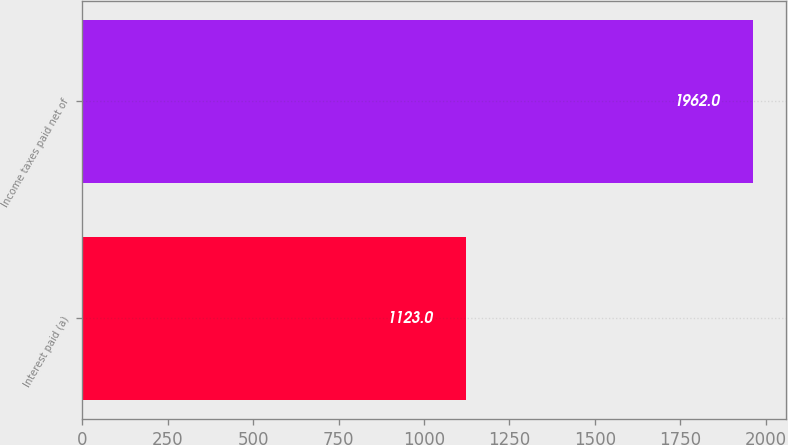Convert chart to OTSL. <chart><loc_0><loc_0><loc_500><loc_500><bar_chart><fcel>Interest paid (a)<fcel>Income taxes paid net of<nl><fcel>1123<fcel>1962<nl></chart> 